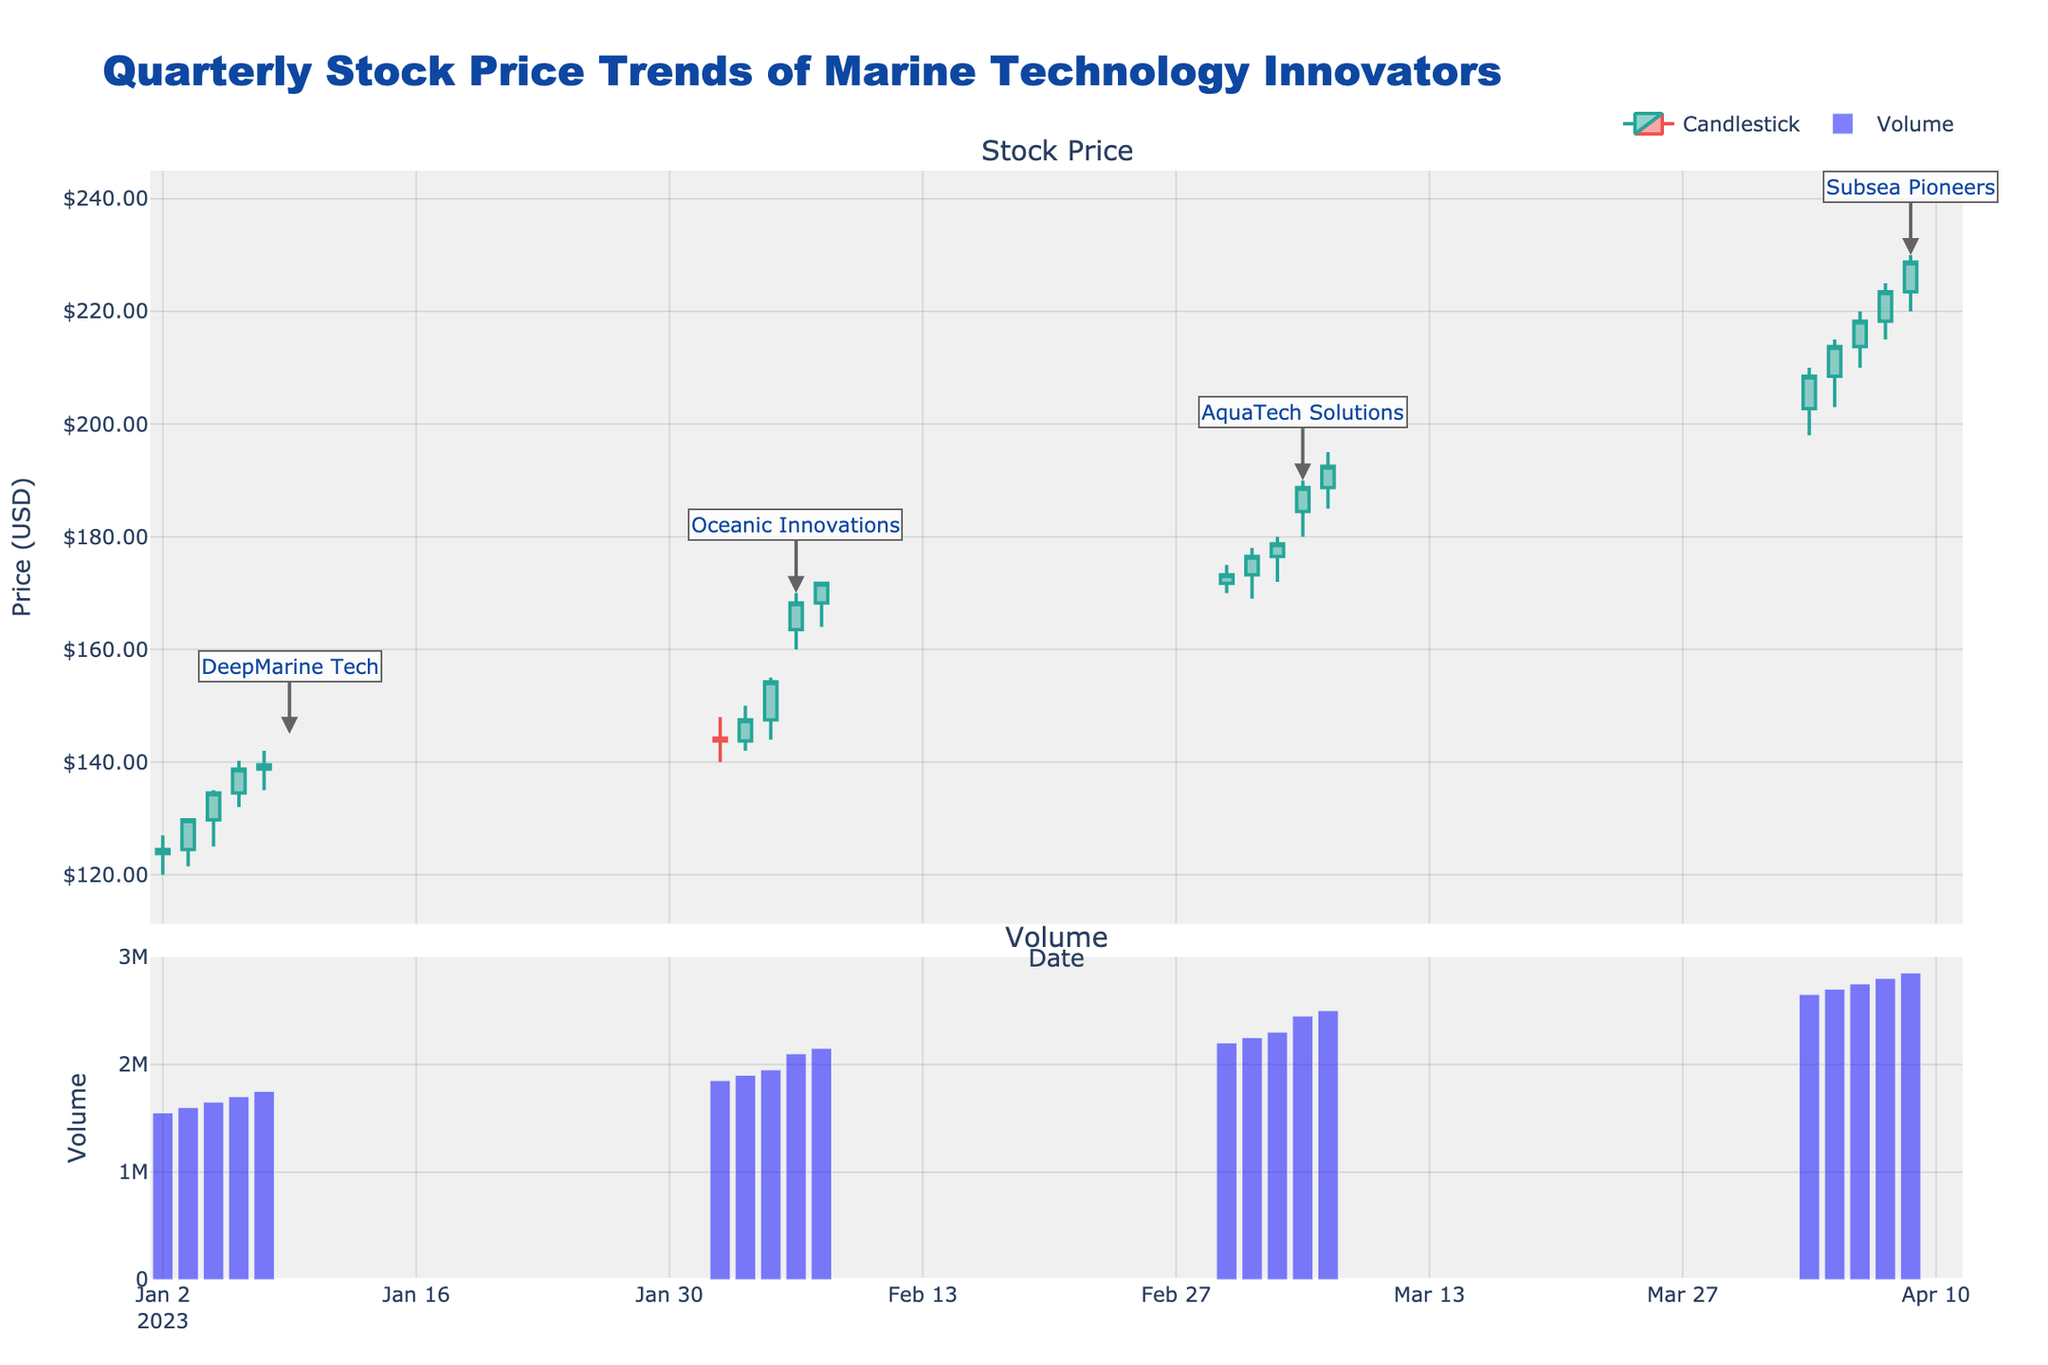What is the highest stock price reached by DeepMarine Tech in January? Look at the candlestick plot for the January dates corresponding to "DeepMarine Tech" and find the highest point on those candlesticks. The highest stock price for DeepMarine Tech in January was on January 5th, with a High price of $140.25.
Answer: $140.25 What was the average closing price of Oceanic Innovations in February? Identify the closing prices of Oceanic Innovations for each date in February: $143.75, $147.50, $154.25, $159.75, $163.50, $168.25. Summing these gives $837.00. Dividing by the 6 data points: $837.00 / 6 = $139.50.
Answer: $139.50 Which company had the highest trading volume, and on which date? Look at the bar chart representing trading volumes and the corresponding dates under the highest bar. The highest trading volume is for Subsea Pioneers on April 7th, with a volume of 2,850,000.
Answer: Subsea Pioneers on April 7 How did the closing price of AquaTech Solutions change from March 1st to March 7th? Note the closing price on March 1st ($173.25) and on March 7th ($192.50). Calculate the change by subtracting the March 1st closing price from the March 7th closing price: $192.50 - $173.25 = $19.25.
Answer: Increased by $19.25 Which company experienced the steepest price increase within their time period, and what was that increase? Calculate the price increase for each company by subtracting the lowest starting price from the highest closing price within their respective time periods. The steepest increase is for Subsea Pioneers from a low of $190.00 to a close of $228.75 on April 7th, making an increase of $38.75.
Answer: Subsea Pioneers with an increase of $38.75 Was there any company that had a decreasing trend in their stock prices? Evaluate the closing prices of each company over their respective time periods to identify any decreasing trends. All companies show an increasing trend because their individual closing prices are higher towards the end of their period compared to the beginning.
Answer: No How did the volume trend for AquaTech Solutions compare to DeepMarine Tech? Look at the volume bar charts for both companies. Notice that AquaTech Solutions shows a general increasing trend in volumes over time, while DeepMarine Tech also shows an increasing trend. They both exhibit a similar increasing volume trend.
Answer: Similar increasing trend What's the lowest price AquaTech Solutions reached in March? Locate the lowest price point on the candlestick for AquaTech Solutions in March. The lowest price was $169.00 on March 2nd.
Answer: $169.00 